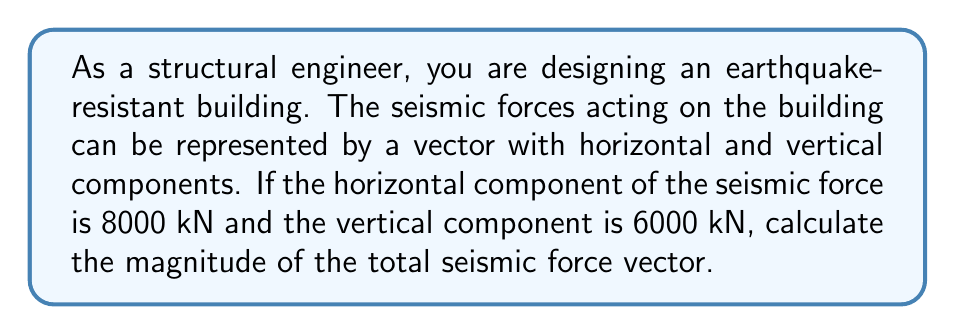Could you help me with this problem? To solve this problem, we need to use the Pythagorean theorem, as the seismic force vector can be represented in a 2D plane with horizontal and vertical components.

Let's define our variables:
$F_h$ = horizontal component of seismic force = 8000 kN
$F_v$ = vertical component of seismic force = 6000 kN
$F_t$ = total magnitude of seismic force vector (what we need to find)

Using the Pythagorean theorem:

$$F_t^2 = F_h^2 + F_v^2$$

Substituting the given values:

$$F_t^2 = (8000\text{ kN})^2 + (6000\text{ kN})^2$$

Simplifying:

$$F_t^2 = 64,000,000\text{ kN}^2 + 36,000,000\text{ kN}^2 = 100,000,000\text{ kN}^2$$

Taking the square root of both sides:

$$F_t = \sqrt{100,000,000\text{ kN}^2} = 10,000\text{ kN}$$

Therefore, the magnitude of the total seismic force vector is 10,000 kN.

[asy]
unitsize(0.1cm);
draw((0,0)--(80,0), arrow=Arrow(TeXHead));
draw((0,0)--(0,60), arrow=Arrow(TeXHead));
draw((0,0)--(80,60), arrow=Arrow(TeXHead));
label("8000 kN", (40,-5));
label("6000 kN", (-5,30));
label("10,000 kN", (50,40));
label("$F_h$", (80,0), E);
label("$F_v$", (0,60), N);
label("$F_t$", (80,60), NE);
[/asy]
Answer: The magnitude of the total seismic force vector is 10,000 kN. 